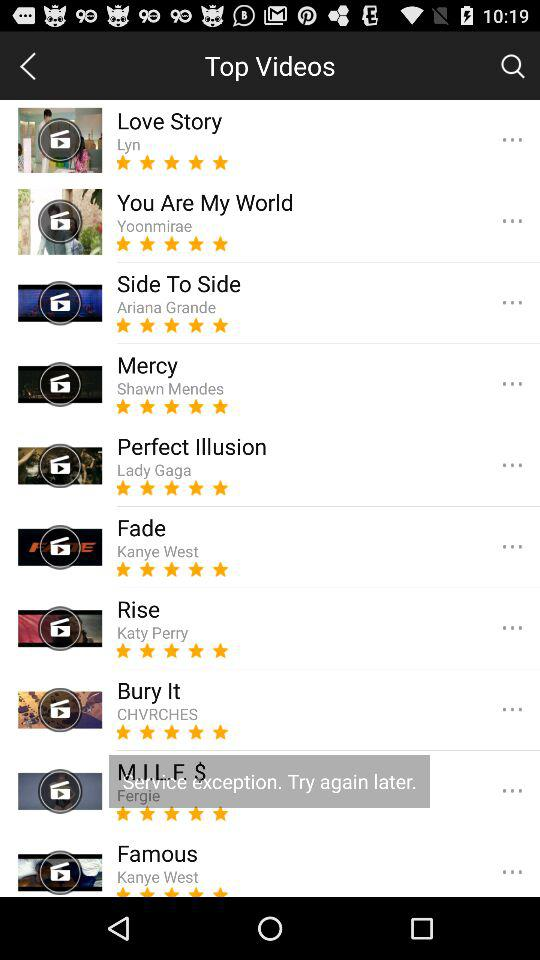What singer's song is Mercy? The singer's name is "Shawn Mendes". 